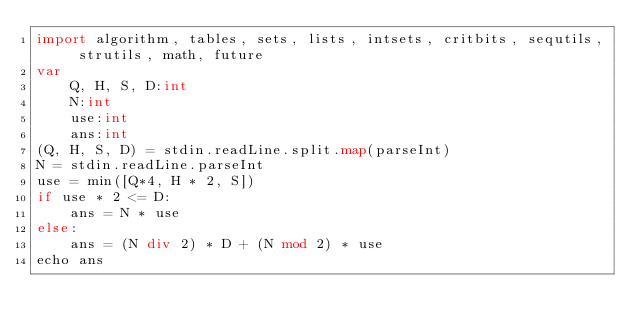Convert code to text. <code><loc_0><loc_0><loc_500><loc_500><_Nim_>import algorithm, tables, sets, lists, intsets, critbits, sequtils, strutils, math, future
var
    Q, H, S, D:int
    N:int
    use:int
    ans:int
(Q, H, S, D) = stdin.readLine.split.map(parseInt)
N = stdin.readLine.parseInt
use = min([Q*4, H * 2, S])
if use * 2 <= D:
    ans = N * use
else:
    ans = (N div 2) * D + (N mod 2) * use
echo ans</code> 